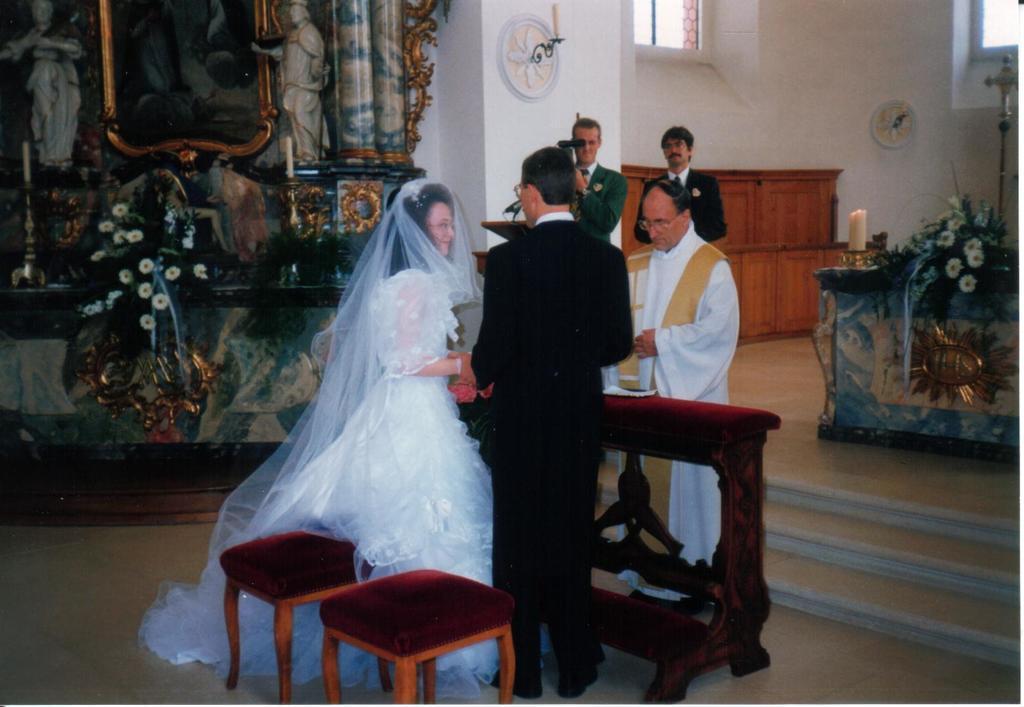How would you summarize this image in a sentence or two? In this image we can see a couple getting engaged. There is a person standing and he is on the right side. Here we can see two persons standing and the person on the left side is recording a video. Here we can observe two statue and a photo frame in the center. 